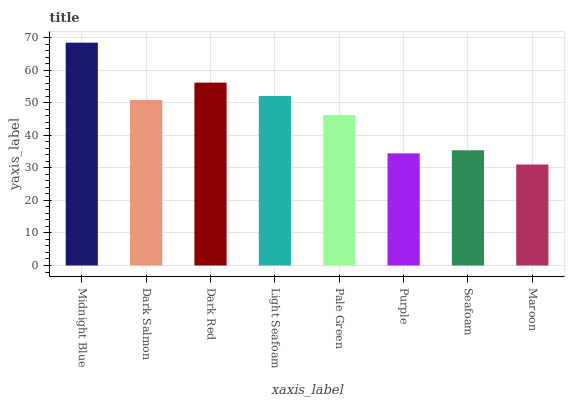Is Dark Salmon the minimum?
Answer yes or no. No. Is Dark Salmon the maximum?
Answer yes or no. No. Is Midnight Blue greater than Dark Salmon?
Answer yes or no. Yes. Is Dark Salmon less than Midnight Blue?
Answer yes or no. Yes. Is Dark Salmon greater than Midnight Blue?
Answer yes or no. No. Is Midnight Blue less than Dark Salmon?
Answer yes or no. No. Is Dark Salmon the high median?
Answer yes or no. Yes. Is Pale Green the low median?
Answer yes or no. Yes. Is Seafoam the high median?
Answer yes or no. No. Is Dark Red the low median?
Answer yes or no. No. 